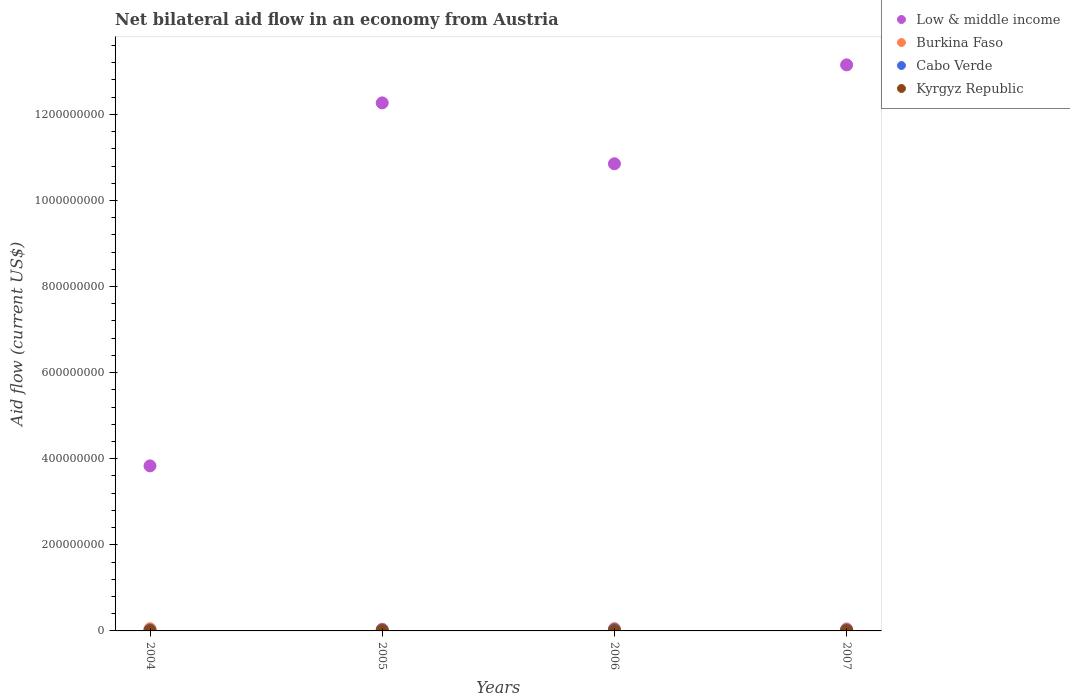How many different coloured dotlines are there?
Offer a very short reply. 4. Across all years, what is the maximum net bilateral aid flow in Low & middle income?
Keep it short and to the point. 1.32e+09. Across all years, what is the minimum net bilateral aid flow in Cabo Verde?
Make the answer very short. 2.01e+06. In which year was the net bilateral aid flow in Cabo Verde maximum?
Offer a terse response. 2006. In which year was the net bilateral aid flow in Burkina Faso minimum?
Offer a very short reply. 2005. What is the total net bilateral aid flow in Cabo Verde in the graph?
Provide a short and direct response. 1.01e+07. What is the difference between the net bilateral aid flow in Burkina Faso in 2004 and that in 2007?
Ensure brevity in your answer.  3.80e+05. What is the difference between the net bilateral aid flow in Burkina Faso in 2006 and the net bilateral aid flow in Cabo Verde in 2004?
Your response must be concise. 3.44e+06. What is the average net bilateral aid flow in Low & middle income per year?
Your answer should be very brief. 1.00e+09. In the year 2005, what is the difference between the net bilateral aid flow in Burkina Faso and net bilateral aid flow in Low & middle income?
Keep it short and to the point. -1.22e+09. In how many years, is the net bilateral aid flow in Low & middle income greater than 720000000 US$?
Offer a very short reply. 3. What is the ratio of the net bilateral aid flow in Cabo Verde in 2004 to that in 2006?
Your answer should be compact. 0.66. Is the net bilateral aid flow in Burkina Faso in 2004 less than that in 2006?
Your answer should be very brief. Yes. Is the difference between the net bilateral aid flow in Burkina Faso in 2005 and 2006 greater than the difference between the net bilateral aid flow in Low & middle income in 2005 and 2006?
Make the answer very short. No. In how many years, is the net bilateral aid flow in Burkina Faso greater than the average net bilateral aid flow in Burkina Faso taken over all years?
Keep it short and to the point. 2. Is the sum of the net bilateral aid flow in Kyrgyz Republic in 2005 and 2006 greater than the maximum net bilateral aid flow in Low & middle income across all years?
Your response must be concise. No. Is it the case that in every year, the sum of the net bilateral aid flow in Kyrgyz Republic and net bilateral aid flow in Cabo Verde  is greater than the sum of net bilateral aid flow in Low & middle income and net bilateral aid flow in Burkina Faso?
Keep it short and to the point. No. Is the net bilateral aid flow in Burkina Faso strictly greater than the net bilateral aid flow in Low & middle income over the years?
Ensure brevity in your answer.  No. What is the difference between two consecutive major ticks on the Y-axis?
Give a very brief answer. 2.00e+08. Are the values on the major ticks of Y-axis written in scientific E-notation?
Provide a short and direct response. No. How many legend labels are there?
Your answer should be compact. 4. What is the title of the graph?
Your response must be concise. Net bilateral aid flow in an economy from Austria. Does "Rwanda" appear as one of the legend labels in the graph?
Your response must be concise. No. What is the label or title of the X-axis?
Provide a succinct answer. Years. What is the Aid flow (current US$) in Low & middle income in 2004?
Give a very brief answer. 3.83e+08. What is the Aid flow (current US$) of Burkina Faso in 2004?
Give a very brief answer. 5.06e+06. What is the Aid flow (current US$) of Cabo Verde in 2004?
Your answer should be compact. 2.01e+06. What is the Aid flow (current US$) of Kyrgyz Republic in 2004?
Provide a short and direct response. 5.10e+05. What is the Aid flow (current US$) in Low & middle income in 2005?
Give a very brief answer. 1.23e+09. What is the Aid flow (current US$) in Burkina Faso in 2005?
Your answer should be compact. 4.13e+06. What is the Aid flow (current US$) in Cabo Verde in 2005?
Make the answer very short. 2.50e+06. What is the Aid flow (current US$) in Low & middle income in 2006?
Keep it short and to the point. 1.09e+09. What is the Aid flow (current US$) in Burkina Faso in 2006?
Your response must be concise. 5.45e+06. What is the Aid flow (current US$) in Cabo Verde in 2006?
Your answer should be compact. 3.05e+06. What is the Aid flow (current US$) of Low & middle income in 2007?
Keep it short and to the point. 1.32e+09. What is the Aid flow (current US$) of Burkina Faso in 2007?
Give a very brief answer. 4.68e+06. What is the Aid flow (current US$) in Cabo Verde in 2007?
Ensure brevity in your answer.  2.54e+06. Across all years, what is the maximum Aid flow (current US$) of Low & middle income?
Give a very brief answer. 1.32e+09. Across all years, what is the maximum Aid flow (current US$) of Burkina Faso?
Your answer should be very brief. 5.45e+06. Across all years, what is the maximum Aid flow (current US$) of Cabo Verde?
Your answer should be very brief. 3.05e+06. Across all years, what is the maximum Aid flow (current US$) of Kyrgyz Republic?
Offer a terse response. 5.10e+05. Across all years, what is the minimum Aid flow (current US$) in Low & middle income?
Provide a succinct answer. 3.83e+08. Across all years, what is the minimum Aid flow (current US$) in Burkina Faso?
Keep it short and to the point. 4.13e+06. Across all years, what is the minimum Aid flow (current US$) of Cabo Verde?
Give a very brief answer. 2.01e+06. Across all years, what is the minimum Aid flow (current US$) in Kyrgyz Republic?
Give a very brief answer. 2.20e+05. What is the total Aid flow (current US$) of Low & middle income in the graph?
Give a very brief answer. 4.01e+09. What is the total Aid flow (current US$) in Burkina Faso in the graph?
Make the answer very short. 1.93e+07. What is the total Aid flow (current US$) of Cabo Verde in the graph?
Make the answer very short. 1.01e+07. What is the total Aid flow (current US$) of Kyrgyz Republic in the graph?
Provide a short and direct response. 1.63e+06. What is the difference between the Aid flow (current US$) in Low & middle income in 2004 and that in 2005?
Your answer should be very brief. -8.43e+08. What is the difference between the Aid flow (current US$) in Burkina Faso in 2004 and that in 2005?
Offer a terse response. 9.30e+05. What is the difference between the Aid flow (current US$) in Cabo Verde in 2004 and that in 2005?
Your answer should be compact. -4.90e+05. What is the difference between the Aid flow (current US$) of Kyrgyz Republic in 2004 and that in 2005?
Offer a very short reply. 3.00e+04. What is the difference between the Aid flow (current US$) of Low & middle income in 2004 and that in 2006?
Make the answer very short. -7.02e+08. What is the difference between the Aid flow (current US$) in Burkina Faso in 2004 and that in 2006?
Give a very brief answer. -3.90e+05. What is the difference between the Aid flow (current US$) in Cabo Verde in 2004 and that in 2006?
Provide a succinct answer. -1.04e+06. What is the difference between the Aid flow (current US$) in Low & middle income in 2004 and that in 2007?
Offer a very short reply. -9.32e+08. What is the difference between the Aid flow (current US$) of Cabo Verde in 2004 and that in 2007?
Give a very brief answer. -5.30e+05. What is the difference between the Aid flow (current US$) of Kyrgyz Republic in 2004 and that in 2007?
Your answer should be compact. 9.00e+04. What is the difference between the Aid flow (current US$) of Low & middle income in 2005 and that in 2006?
Offer a terse response. 1.41e+08. What is the difference between the Aid flow (current US$) of Burkina Faso in 2005 and that in 2006?
Provide a short and direct response. -1.32e+06. What is the difference between the Aid flow (current US$) in Cabo Verde in 2005 and that in 2006?
Your answer should be compact. -5.50e+05. What is the difference between the Aid flow (current US$) of Kyrgyz Republic in 2005 and that in 2006?
Your answer should be compact. 2.60e+05. What is the difference between the Aid flow (current US$) of Low & middle income in 2005 and that in 2007?
Provide a succinct answer. -8.83e+07. What is the difference between the Aid flow (current US$) in Burkina Faso in 2005 and that in 2007?
Provide a succinct answer. -5.50e+05. What is the difference between the Aid flow (current US$) in Low & middle income in 2006 and that in 2007?
Ensure brevity in your answer.  -2.30e+08. What is the difference between the Aid flow (current US$) of Burkina Faso in 2006 and that in 2007?
Offer a terse response. 7.70e+05. What is the difference between the Aid flow (current US$) of Cabo Verde in 2006 and that in 2007?
Provide a succinct answer. 5.10e+05. What is the difference between the Aid flow (current US$) in Low & middle income in 2004 and the Aid flow (current US$) in Burkina Faso in 2005?
Ensure brevity in your answer.  3.79e+08. What is the difference between the Aid flow (current US$) of Low & middle income in 2004 and the Aid flow (current US$) of Cabo Verde in 2005?
Your answer should be compact. 3.81e+08. What is the difference between the Aid flow (current US$) of Low & middle income in 2004 and the Aid flow (current US$) of Kyrgyz Republic in 2005?
Your answer should be compact. 3.83e+08. What is the difference between the Aid flow (current US$) in Burkina Faso in 2004 and the Aid flow (current US$) in Cabo Verde in 2005?
Give a very brief answer. 2.56e+06. What is the difference between the Aid flow (current US$) of Burkina Faso in 2004 and the Aid flow (current US$) of Kyrgyz Republic in 2005?
Ensure brevity in your answer.  4.58e+06. What is the difference between the Aid flow (current US$) of Cabo Verde in 2004 and the Aid flow (current US$) of Kyrgyz Republic in 2005?
Offer a terse response. 1.53e+06. What is the difference between the Aid flow (current US$) in Low & middle income in 2004 and the Aid flow (current US$) in Burkina Faso in 2006?
Provide a short and direct response. 3.78e+08. What is the difference between the Aid flow (current US$) in Low & middle income in 2004 and the Aid flow (current US$) in Cabo Verde in 2006?
Offer a terse response. 3.80e+08. What is the difference between the Aid flow (current US$) of Low & middle income in 2004 and the Aid flow (current US$) of Kyrgyz Republic in 2006?
Provide a succinct answer. 3.83e+08. What is the difference between the Aid flow (current US$) in Burkina Faso in 2004 and the Aid flow (current US$) in Cabo Verde in 2006?
Provide a short and direct response. 2.01e+06. What is the difference between the Aid flow (current US$) in Burkina Faso in 2004 and the Aid flow (current US$) in Kyrgyz Republic in 2006?
Give a very brief answer. 4.84e+06. What is the difference between the Aid flow (current US$) of Cabo Verde in 2004 and the Aid flow (current US$) of Kyrgyz Republic in 2006?
Keep it short and to the point. 1.79e+06. What is the difference between the Aid flow (current US$) of Low & middle income in 2004 and the Aid flow (current US$) of Burkina Faso in 2007?
Provide a short and direct response. 3.79e+08. What is the difference between the Aid flow (current US$) of Low & middle income in 2004 and the Aid flow (current US$) of Cabo Verde in 2007?
Offer a terse response. 3.81e+08. What is the difference between the Aid flow (current US$) in Low & middle income in 2004 and the Aid flow (current US$) in Kyrgyz Republic in 2007?
Ensure brevity in your answer.  3.83e+08. What is the difference between the Aid flow (current US$) in Burkina Faso in 2004 and the Aid flow (current US$) in Cabo Verde in 2007?
Ensure brevity in your answer.  2.52e+06. What is the difference between the Aid flow (current US$) of Burkina Faso in 2004 and the Aid flow (current US$) of Kyrgyz Republic in 2007?
Ensure brevity in your answer.  4.64e+06. What is the difference between the Aid flow (current US$) in Cabo Verde in 2004 and the Aid flow (current US$) in Kyrgyz Republic in 2007?
Ensure brevity in your answer.  1.59e+06. What is the difference between the Aid flow (current US$) in Low & middle income in 2005 and the Aid flow (current US$) in Burkina Faso in 2006?
Ensure brevity in your answer.  1.22e+09. What is the difference between the Aid flow (current US$) of Low & middle income in 2005 and the Aid flow (current US$) of Cabo Verde in 2006?
Offer a very short reply. 1.22e+09. What is the difference between the Aid flow (current US$) of Low & middle income in 2005 and the Aid flow (current US$) of Kyrgyz Republic in 2006?
Give a very brief answer. 1.23e+09. What is the difference between the Aid flow (current US$) in Burkina Faso in 2005 and the Aid flow (current US$) in Cabo Verde in 2006?
Provide a short and direct response. 1.08e+06. What is the difference between the Aid flow (current US$) in Burkina Faso in 2005 and the Aid flow (current US$) in Kyrgyz Republic in 2006?
Your answer should be very brief. 3.91e+06. What is the difference between the Aid flow (current US$) of Cabo Verde in 2005 and the Aid flow (current US$) of Kyrgyz Republic in 2006?
Offer a very short reply. 2.28e+06. What is the difference between the Aid flow (current US$) of Low & middle income in 2005 and the Aid flow (current US$) of Burkina Faso in 2007?
Offer a terse response. 1.22e+09. What is the difference between the Aid flow (current US$) of Low & middle income in 2005 and the Aid flow (current US$) of Cabo Verde in 2007?
Your answer should be very brief. 1.22e+09. What is the difference between the Aid flow (current US$) of Low & middle income in 2005 and the Aid flow (current US$) of Kyrgyz Republic in 2007?
Make the answer very short. 1.23e+09. What is the difference between the Aid flow (current US$) of Burkina Faso in 2005 and the Aid flow (current US$) of Cabo Verde in 2007?
Your answer should be very brief. 1.59e+06. What is the difference between the Aid flow (current US$) of Burkina Faso in 2005 and the Aid flow (current US$) of Kyrgyz Republic in 2007?
Make the answer very short. 3.71e+06. What is the difference between the Aid flow (current US$) in Cabo Verde in 2005 and the Aid flow (current US$) in Kyrgyz Republic in 2007?
Make the answer very short. 2.08e+06. What is the difference between the Aid flow (current US$) in Low & middle income in 2006 and the Aid flow (current US$) in Burkina Faso in 2007?
Your response must be concise. 1.08e+09. What is the difference between the Aid flow (current US$) in Low & middle income in 2006 and the Aid flow (current US$) in Cabo Verde in 2007?
Provide a succinct answer. 1.08e+09. What is the difference between the Aid flow (current US$) of Low & middle income in 2006 and the Aid flow (current US$) of Kyrgyz Republic in 2007?
Make the answer very short. 1.08e+09. What is the difference between the Aid flow (current US$) in Burkina Faso in 2006 and the Aid flow (current US$) in Cabo Verde in 2007?
Provide a succinct answer. 2.91e+06. What is the difference between the Aid flow (current US$) in Burkina Faso in 2006 and the Aid flow (current US$) in Kyrgyz Republic in 2007?
Your response must be concise. 5.03e+06. What is the difference between the Aid flow (current US$) of Cabo Verde in 2006 and the Aid flow (current US$) of Kyrgyz Republic in 2007?
Offer a very short reply. 2.63e+06. What is the average Aid flow (current US$) in Low & middle income per year?
Your answer should be compact. 1.00e+09. What is the average Aid flow (current US$) in Burkina Faso per year?
Offer a very short reply. 4.83e+06. What is the average Aid flow (current US$) in Cabo Verde per year?
Provide a short and direct response. 2.52e+06. What is the average Aid flow (current US$) of Kyrgyz Republic per year?
Your answer should be very brief. 4.08e+05. In the year 2004, what is the difference between the Aid flow (current US$) of Low & middle income and Aid flow (current US$) of Burkina Faso?
Your response must be concise. 3.78e+08. In the year 2004, what is the difference between the Aid flow (current US$) of Low & middle income and Aid flow (current US$) of Cabo Verde?
Offer a very short reply. 3.81e+08. In the year 2004, what is the difference between the Aid flow (current US$) of Low & middle income and Aid flow (current US$) of Kyrgyz Republic?
Provide a succinct answer. 3.83e+08. In the year 2004, what is the difference between the Aid flow (current US$) in Burkina Faso and Aid flow (current US$) in Cabo Verde?
Keep it short and to the point. 3.05e+06. In the year 2004, what is the difference between the Aid flow (current US$) of Burkina Faso and Aid flow (current US$) of Kyrgyz Republic?
Offer a very short reply. 4.55e+06. In the year 2004, what is the difference between the Aid flow (current US$) in Cabo Verde and Aid flow (current US$) in Kyrgyz Republic?
Ensure brevity in your answer.  1.50e+06. In the year 2005, what is the difference between the Aid flow (current US$) of Low & middle income and Aid flow (current US$) of Burkina Faso?
Give a very brief answer. 1.22e+09. In the year 2005, what is the difference between the Aid flow (current US$) of Low & middle income and Aid flow (current US$) of Cabo Verde?
Make the answer very short. 1.22e+09. In the year 2005, what is the difference between the Aid flow (current US$) in Low & middle income and Aid flow (current US$) in Kyrgyz Republic?
Your answer should be compact. 1.23e+09. In the year 2005, what is the difference between the Aid flow (current US$) of Burkina Faso and Aid flow (current US$) of Cabo Verde?
Offer a very short reply. 1.63e+06. In the year 2005, what is the difference between the Aid flow (current US$) in Burkina Faso and Aid flow (current US$) in Kyrgyz Republic?
Provide a succinct answer. 3.65e+06. In the year 2005, what is the difference between the Aid flow (current US$) of Cabo Verde and Aid flow (current US$) of Kyrgyz Republic?
Make the answer very short. 2.02e+06. In the year 2006, what is the difference between the Aid flow (current US$) of Low & middle income and Aid flow (current US$) of Burkina Faso?
Your answer should be compact. 1.08e+09. In the year 2006, what is the difference between the Aid flow (current US$) of Low & middle income and Aid flow (current US$) of Cabo Verde?
Provide a short and direct response. 1.08e+09. In the year 2006, what is the difference between the Aid flow (current US$) of Low & middle income and Aid flow (current US$) of Kyrgyz Republic?
Your answer should be compact. 1.09e+09. In the year 2006, what is the difference between the Aid flow (current US$) of Burkina Faso and Aid flow (current US$) of Cabo Verde?
Offer a very short reply. 2.40e+06. In the year 2006, what is the difference between the Aid flow (current US$) of Burkina Faso and Aid flow (current US$) of Kyrgyz Republic?
Offer a terse response. 5.23e+06. In the year 2006, what is the difference between the Aid flow (current US$) of Cabo Verde and Aid flow (current US$) of Kyrgyz Republic?
Offer a very short reply. 2.83e+06. In the year 2007, what is the difference between the Aid flow (current US$) in Low & middle income and Aid flow (current US$) in Burkina Faso?
Offer a terse response. 1.31e+09. In the year 2007, what is the difference between the Aid flow (current US$) of Low & middle income and Aid flow (current US$) of Cabo Verde?
Give a very brief answer. 1.31e+09. In the year 2007, what is the difference between the Aid flow (current US$) in Low & middle income and Aid flow (current US$) in Kyrgyz Republic?
Your response must be concise. 1.31e+09. In the year 2007, what is the difference between the Aid flow (current US$) of Burkina Faso and Aid flow (current US$) of Cabo Verde?
Provide a succinct answer. 2.14e+06. In the year 2007, what is the difference between the Aid flow (current US$) in Burkina Faso and Aid flow (current US$) in Kyrgyz Republic?
Keep it short and to the point. 4.26e+06. In the year 2007, what is the difference between the Aid flow (current US$) in Cabo Verde and Aid flow (current US$) in Kyrgyz Republic?
Provide a succinct answer. 2.12e+06. What is the ratio of the Aid flow (current US$) of Low & middle income in 2004 to that in 2005?
Your answer should be compact. 0.31. What is the ratio of the Aid flow (current US$) of Burkina Faso in 2004 to that in 2005?
Offer a very short reply. 1.23. What is the ratio of the Aid flow (current US$) in Cabo Verde in 2004 to that in 2005?
Offer a terse response. 0.8. What is the ratio of the Aid flow (current US$) in Kyrgyz Republic in 2004 to that in 2005?
Provide a short and direct response. 1.06. What is the ratio of the Aid flow (current US$) of Low & middle income in 2004 to that in 2006?
Your answer should be very brief. 0.35. What is the ratio of the Aid flow (current US$) of Burkina Faso in 2004 to that in 2006?
Your answer should be very brief. 0.93. What is the ratio of the Aid flow (current US$) in Cabo Verde in 2004 to that in 2006?
Offer a terse response. 0.66. What is the ratio of the Aid flow (current US$) in Kyrgyz Republic in 2004 to that in 2006?
Ensure brevity in your answer.  2.32. What is the ratio of the Aid flow (current US$) of Low & middle income in 2004 to that in 2007?
Your answer should be very brief. 0.29. What is the ratio of the Aid flow (current US$) in Burkina Faso in 2004 to that in 2007?
Offer a very short reply. 1.08. What is the ratio of the Aid flow (current US$) of Cabo Verde in 2004 to that in 2007?
Keep it short and to the point. 0.79. What is the ratio of the Aid flow (current US$) of Kyrgyz Republic in 2004 to that in 2007?
Make the answer very short. 1.21. What is the ratio of the Aid flow (current US$) in Low & middle income in 2005 to that in 2006?
Offer a terse response. 1.13. What is the ratio of the Aid flow (current US$) in Burkina Faso in 2005 to that in 2006?
Your answer should be very brief. 0.76. What is the ratio of the Aid flow (current US$) of Cabo Verde in 2005 to that in 2006?
Keep it short and to the point. 0.82. What is the ratio of the Aid flow (current US$) in Kyrgyz Republic in 2005 to that in 2006?
Ensure brevity in your answer.  2.18. What is the ratio of the Aid flow (current US$) in Low & middle income in 2005 to that in 2007?
Provide a short and direct response. 0.93. What is the ratio of the Aid flow (current US$) in Burkina Faso in 2005 to that in 2007?
Offer a terse response. 0.88. What is the ratio of the Aid flow (current US$) in Cabo Verde in 2005 to that in 2007?
Your answer should be very brief. 0.98. What is the ratio of the Aid flow (current US$) in Kyrgyz Republic in 2005 to that in 2007?
Your response must be concise. 1.14. What is the ratio of the Aid flow (current US$) of Low & middle income in 2006 to that in 2007?
Your answer should be very brief. 0.83. What is the ratio of the Aid flow (current US$) of Burkina Faso in 2006 to that in 2007?
Keep it short and to the point. 1.16. What is the ratio of the Aid flow (current US$) of Cabo Verde in 2006 to that in 2007?
Ensure brevity in your answer.  1.2. What is the ratio of the Aid flow (current US$) in Kyrgyz Republic in 2006 to that in 2007?
Give a very brief answer. 0.52. What is the difference between the highest and the second highest Aid flow (current US$) of Low & middle income?
Give a very brief answer. 8.83e+07. What is the difference between the highest and the second highest Aid flow (current US$) in Cabo Verde?
Provide a short and direct response. 5.10e+05. What is the difference between the highest and the second highest Aid flow (current US$) in Kyrgyz Republic?
Your answer should be very brief. 3.00e+04. What is the difference between the highest and the lowest Aid flow (current US$) of Low & middle income?
Provide a short and direct response. 9.32e+08. What is the difference between the highest and the lowest Aid flow (current US$) of Burkina Faso?
Your response must be concise. 1.32e+06. What is the difference between the highest and the lowest Aid flow (current US$) of Cabo Verde?
Give a very brief answer. 1.04e+06. What is the difference between the highest and the lowest Aid flow (current US$) of Kyrgyz Republic?
Provide a succinct answer. 2.90e+05. 